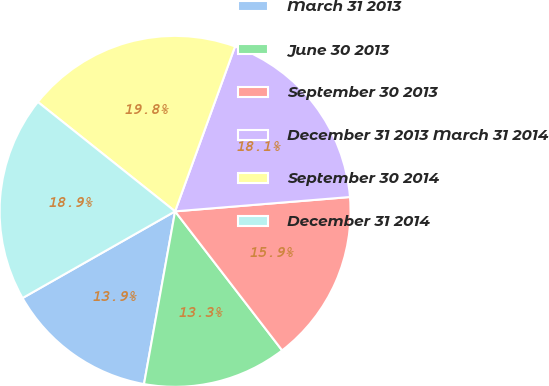Convert chart to OTSL. <chart><loc_0><loc_0><loc_500><loc_500><pie_chart><fcel>March 31 2013<fcel>June 30 2013<fcel>September 30 2013<fcel>December 31 2013 March 31 2014<fcel>September 30 2014<fcel>December 31 2014<nl><fcel>13.94%<fcel>13.28%<fcel>15.86%<fcel>18.15%<fcel>19.84%<fcel>18.94%<nl></chart> 